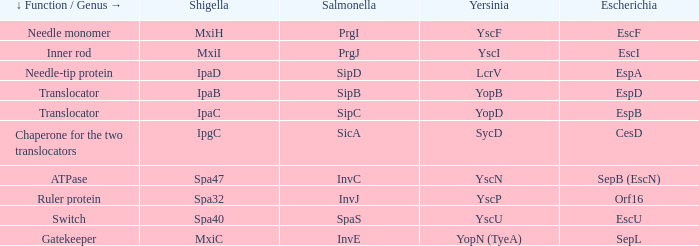What is the shigella equivalent for yersinia yopb? IpaB. 